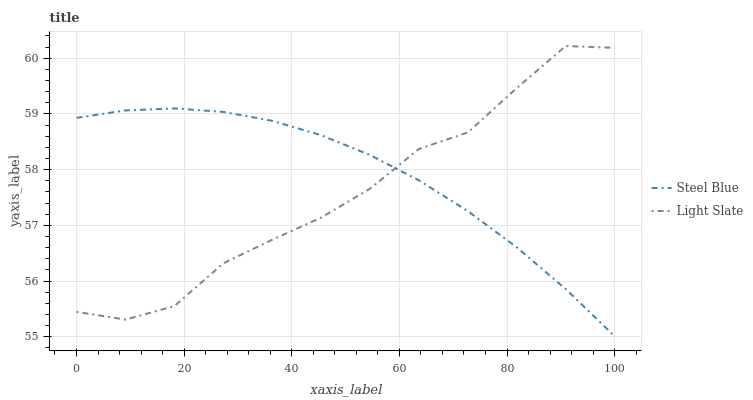Does Light Slate have the minimum area under the curve?
Answer yes or no. Yes. Does Steel Blue have the maximum area under the curve?
Answer yes or no. Yes. Does Steel Blue have the minimum area under the curve?
Answer yes or no. No. Is Steel Blue the smoothest?
Answer yes or no. Yes. Is Light Slate the roughest?
Answer yes or no. Yes. Is Steel Blue the roughest?
Answer yes or no. No. Does Steel Blue have the lowest value?
Answer yes or no. Yes. Does Light Slate have the highest value?
Answer yes or no. Yes. Does Steel Blue have the highest value?
Answer yes or no. No. Does Light Slate intersect Steel Blue?
Answer yes or no. Yes. Is Light Slate less than Steel Blue?
Answer yes or no. No. Is Light Slate greater than Steel Blue?
Answer yes or no. No. 